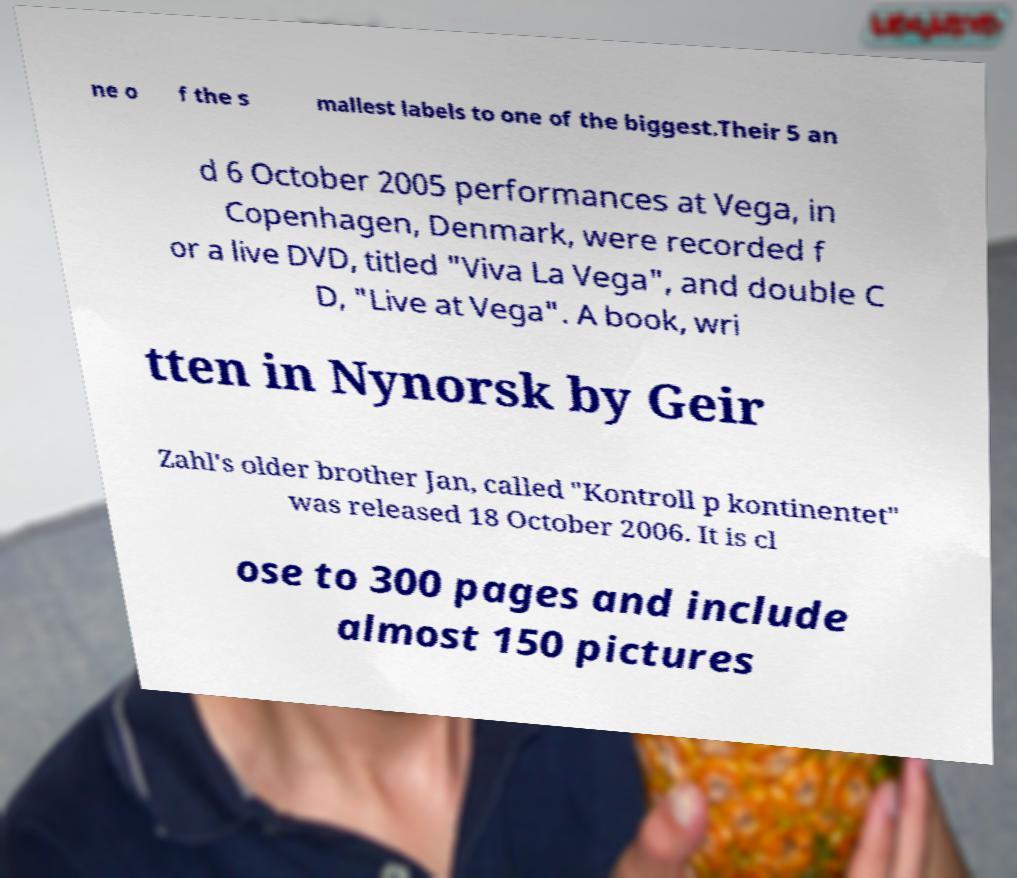Can you accurately transcribe the text from the provided image for me? ne o f the s mallest labels to one of the biggest.Their 5 an d 6 October 2005 performances at Vega, in Copenhagen, Denmark, were recorded f or a live DVD, titled "Viva La Vega", and double C D, "Live at Vega". A book, wri tten in Nynorsk by Geir Zahl's older brother Jan, called "Kontroll p kontinentet" was released 18 October 2006. It is cl ose to 300 pages and include almost 150 pictures 